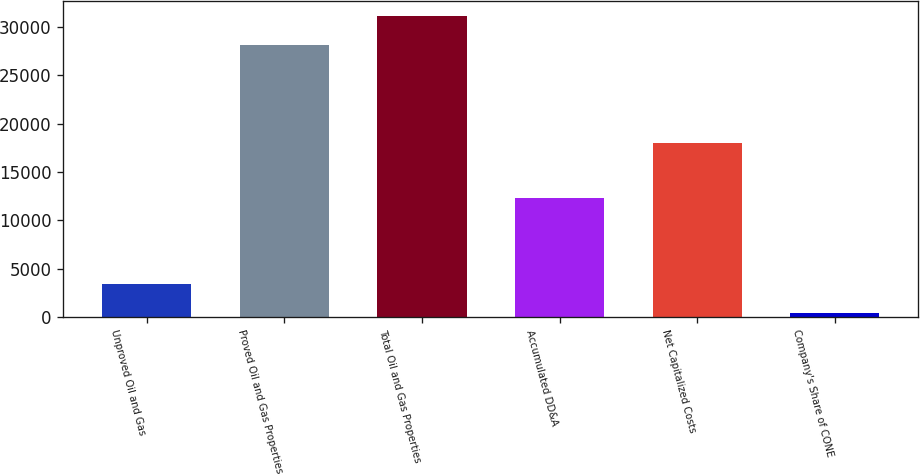<chart> <loc_0><loc_0><loc_500><loc_500><bar_chart><fcel>Unproved Oil and Gas<fcel>Proved Oil and Gas Properties<fcel>Total Oil and Gas Properties<fcel>Accumulated DD&A<fcel>Net Capitalized Costs<fcel>Company's Share of CONE<nl><fcel>3431.5<fcel>28158<fcel>31149.5<fcel>12325<fcel>18030<fcel>440<nl></chart> 